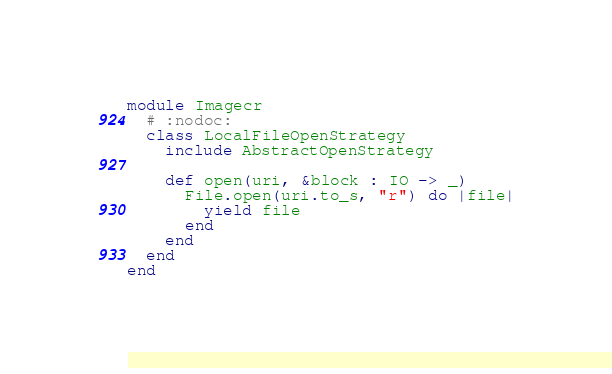<code> <loc_0><loc_0><loc_500><loc_500><_Crystal_>module Imagecr
  # :nodoc:
  class LocalFileOpenStrategy
    include AbstractOpenStrategy

    def open(uri, &block : IO -> _)
      File.open(uri.to_s, "r") do |file|
        yield file
      end
    end
  end
end
</code> 